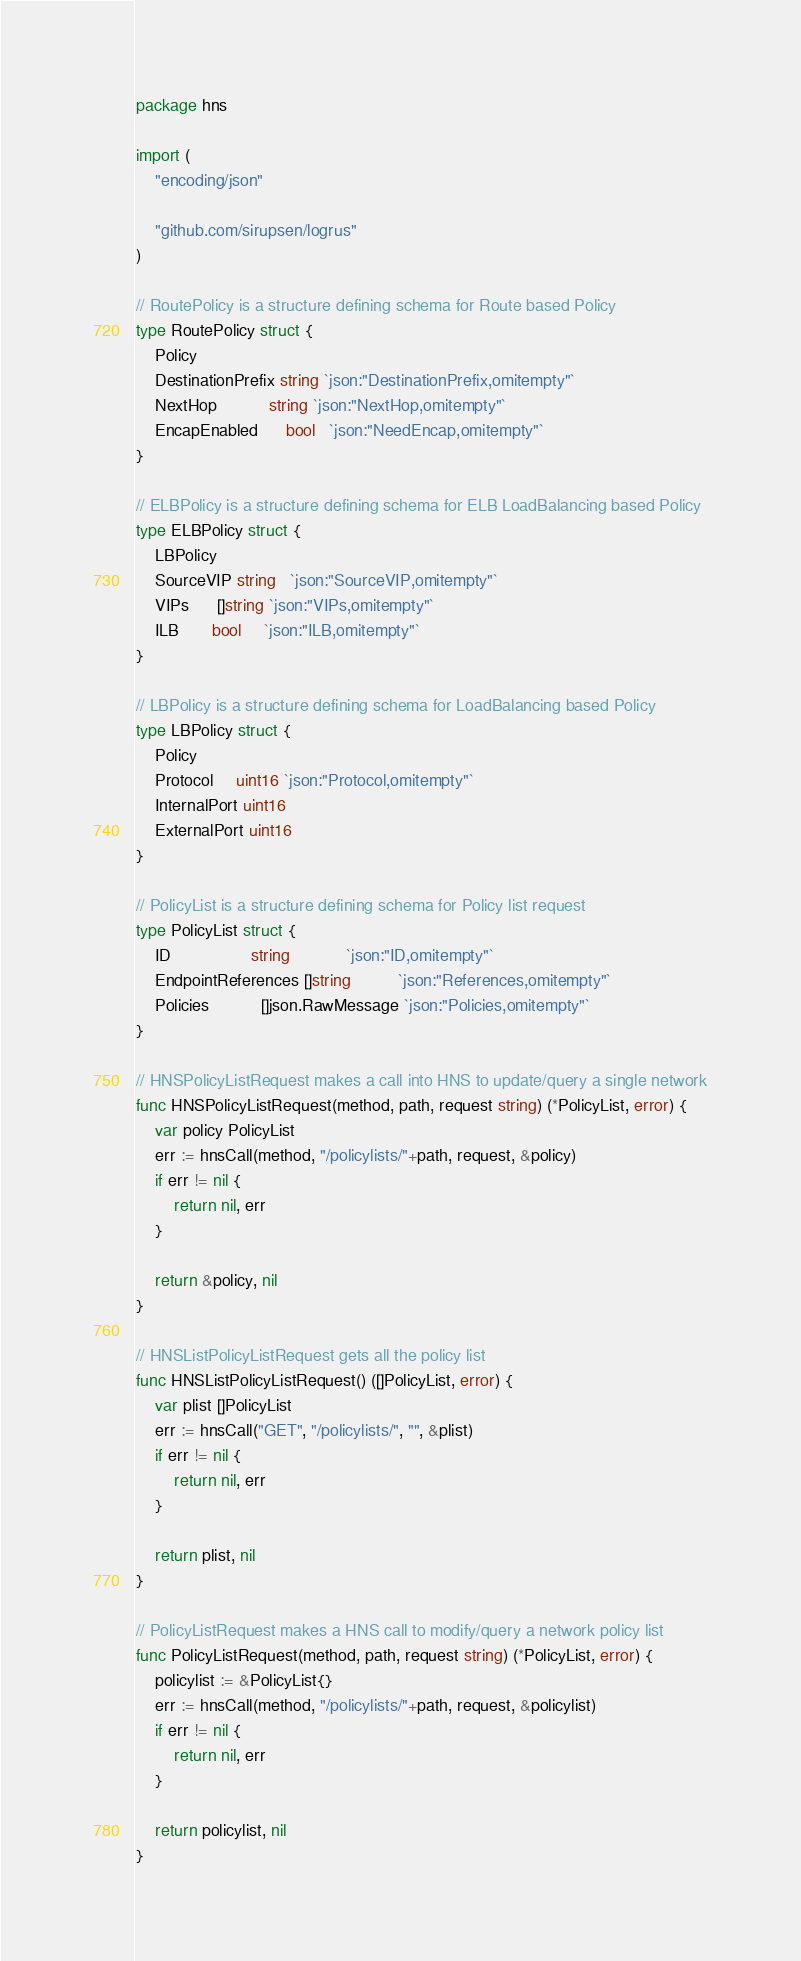<code> <loc_0><loc_0><loc_500><loc_500><_Go_>package hns

import (
	"encoding/json"

	"github.com/sirupsen/logrus"
)

// RoutePolicy is a structure defining schema for Route based Policy
type RoutePolicy struct {
	Policy
	DestinationPrefix string `json:"DestinationPrefix,omitempty"`
	NextHop           string `json:"NextHop,omitempty"`
	EncapEnabled      bool   `json:"NeedEncap,omitempty"`
}

// ELBPolicy is a structure defining schema for ELB LoadBalancing based Policy
type ELBPolicy struct {
	LBPolicy
	SourceVIP string   `json:"SourceVIP,omitempty"`
	VIPs      []string `json:"VIPs,omitempty"`
	ILB       bool     `json:"ILB,omitempty"`
}

// LBPolicy is a structure defining schema for LoadBalancing based Policy
type LBPolicy struct {
	Policy
	Protocol     uint16 `json:"Protocol,omitempty"`
	InternalPort uint16
	ExternalPort uint16
}

// PolicyList is a structure defining schema for Policy list request
type PolicyList struct {
	ID                 string            `json:"ID,omitempty"`
	EndpointReferences []string          `json:"References,omitempty"`
	Policies           []json.RawMessage `json:"Policies,omitempty"`
}

// HNSPolicyListRequest makes a call into HNS to update/query a single network
func HNSPolicyListRequest(method, path, request string) (*PolicyList, error) {
	var policy PolicyList
	err := hnsCall(method, "/policylists/"+path, request, &policy)
	if err != nil {
		return nil, err
	}

	return &policy, nil
}

// HNSListPolicyListRequest gets all the policy list
func HNSListPolicyListRequest() ([]PolicyList, error) {
	var plist []PolicyList
	err := hnsCall("GET", "/policylists/", "", &plist)
	if err != nil {
		return nil, err
	}

	return plist, nil
}

// PolicyListRequest makes a HNS call to modify/query a network policy list
func PolicyListRequest(method, path, request string) (*PolicyList, error) {
	policylist := &PolicyList{}
	err := hnsCall(method, "/policylists/"+path, request, &policylist)
	if err != nil {
		return nil, err
	}

	return policylist, nil
}
</code> 